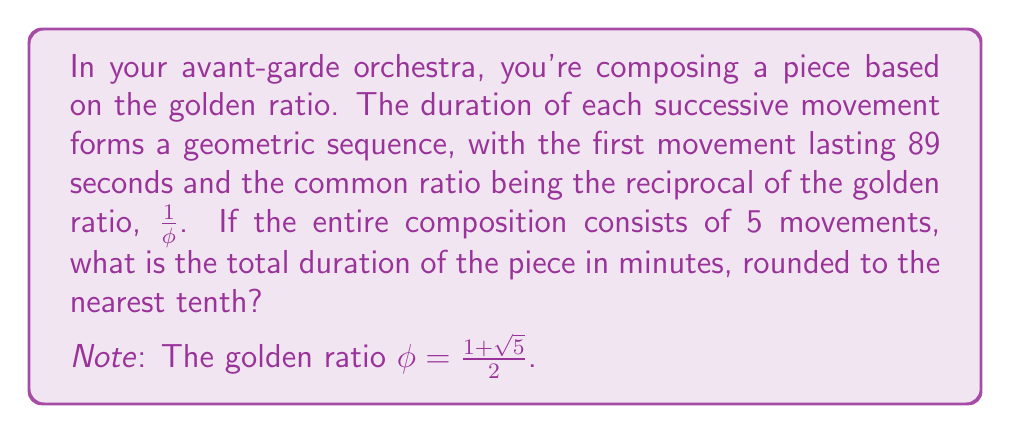Give your solution to this math problem. Let's approach this step-by-step:

1) First, recall that the golden ratio $\phi$ is given by:

   $$\phi = \frac{1+\sqrt{5}}{2} \approx 1.618034$$

2) The common ratio of our geometric sequence is $\frac{1}{\phi}$:

   $$r = \frac{1}{\phi} = \frac{2}{1+\sqrt{5}} \approx 0.618034$$

3) We're given that the first term $a_1 = 89$ seconds. In a geometric sequence, each term is the product of the previous term and the common ratio. So the sequence of movement durations will be:

   $$a_1 = 89$$
   $$a_2 = 89 \cdot \frac{1}{\phi}$$
   $$a_3 = 89 \cdot (\frac{1}{\phi})^2$$
   $$a_4 = 89 \cdot (\frac{1}{\phi})^3$$
   $$a_5 = 89 \cdot (\frac{1}{\phi})^4$$

4) The sum of a geometric sequence is given by the formula:

   $$S_n = \frac{a_1(1-r^n)}{1-r}$$

   where $a_1$ is the first term, $r$ is the common ratio, and $n$ is the number of terms.

5) Substituting our values:

   $$S_5 = \frac{89(1-(\frac{1}{\phi})^5)}{1-\frac{1}{\phi}}$$

6) Simplify:

   $$S_5 = 89 \cdot \frac{\phi(1-(\frac{1}{\phi})^5)}{\phi-1}$$

7) Calculate this value:

   $$S_5 \approx 233.2406 \text{ seconds}$$

8) Convert to minutes:

   $$233.2406 \text{ seconds} = 3.8873 \text{ minutes}$$

9) Rounding to the nearest tenth:

   $$3.8873 \text{ minutes} \approx 3.9 \text{ minutes}$$
Answer: 3.9 minutes 